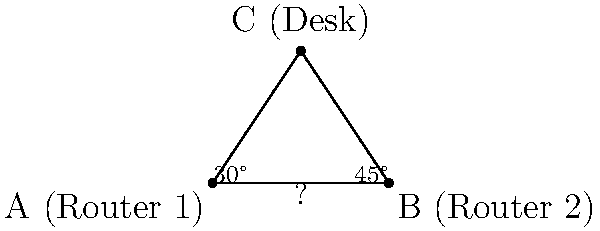In a large office space, two Wi-Fi routers (Router 1 and Router 2) need to be installed to provide optimal coverage. A desk is positioned such that it forms a triangle with the two router locations. Using your latest Wi-Fi signal strength meter from Amazon, you measure the angle between Router 1 and the desk to be 30°, and the angle between Router 2 and the desk to be 45°. If the distance from Router 1 to the desk is 7.2 meters, what is the distance between the two routers? Round your answer to the nearest tenth of a meter. Let's approach this step-by-step using trigonometry:

1) Let's define our triangle:
   - A: Router 1
   - B: Router 2
   - C: Desk
   - AC = 7.2 meters (given)
   - Angle CAB = 30°
   - Angle CBA = 45°

2) We can find angle ACB using the fact that angles in a triangle sum to 180°:
   $ACB = 180° - (30° + 45°) = 105°$

3) Now we can use the sine law:
   $\frac{a}{\sin A} = \frac{b}{\sin B} = \frac{c}{\sin C}$
   
   Where $a$, $b$, and $c$ are the sides opposite to angles $A$, $B$, and $C$ respectively.

4) We want to find AB (the distance between routers). Let's call this distance $x$.
   $\frac{x}{\sin 105°} = \frac{7.2}{\sin 45°}$

5) Solving for $x$:
   $x = \frac{7.2 \cdot \sin 105°}{\sin 45°}$

6) Using a calculator (or programming function):
   $x \approx 9.654$ meters

7) Rounding to the nearest tenth:
   $x \approx 9.7$ meters
Answer: 9.7 meters 